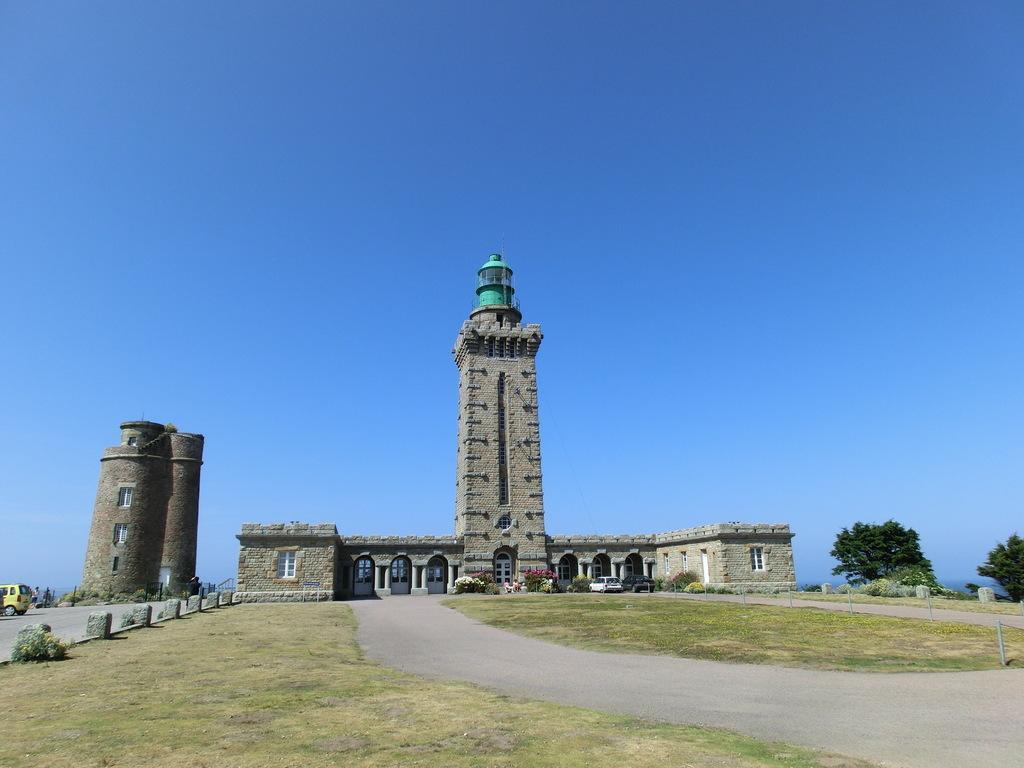Can you describe this image briefly? As we can see in the image there is grass, vehicle, buildings, windows, trees and sky. 